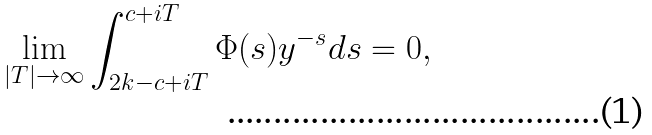Convert formula to latex. <formula><loc_0><loc_0><loc_500><loc_500>\lim _ { | T | \rightarrow \infty } \int _ { 2 k - c + i T } ^ { c + i T } \Phi ( s ) y ^ { - s } d s = 0 ,</formula> 